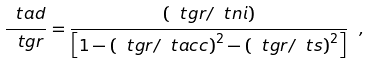Convert formula to latex. <formula><loc_0><loc_0><loc_500><loc_500>\frac { \ t a d } { \ t g r } = \frac { \left ( \ t g r / \ t n i \right ) } { \left [ 1 - \left ( \ t g r / \ t a c c \right ) ^ { 2 } - \left ( \ t g r / \ t s \right ) ^ { 2 } \right ] } \ ,</formula> 